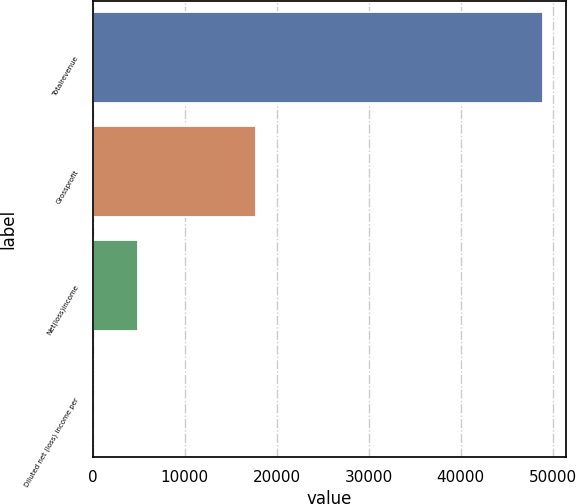<chart> <loc_0><loc_0><loc_500><loc_500><bar_chart><fcel>Totalrevenue<fcel>Grossprofit<fcel>Net(loss)income<fcel>Diluted net (loss) income per<nl><fcel>48964<fcel>17757<fcel>4896.44<fcel>0.05<nl></chart> 